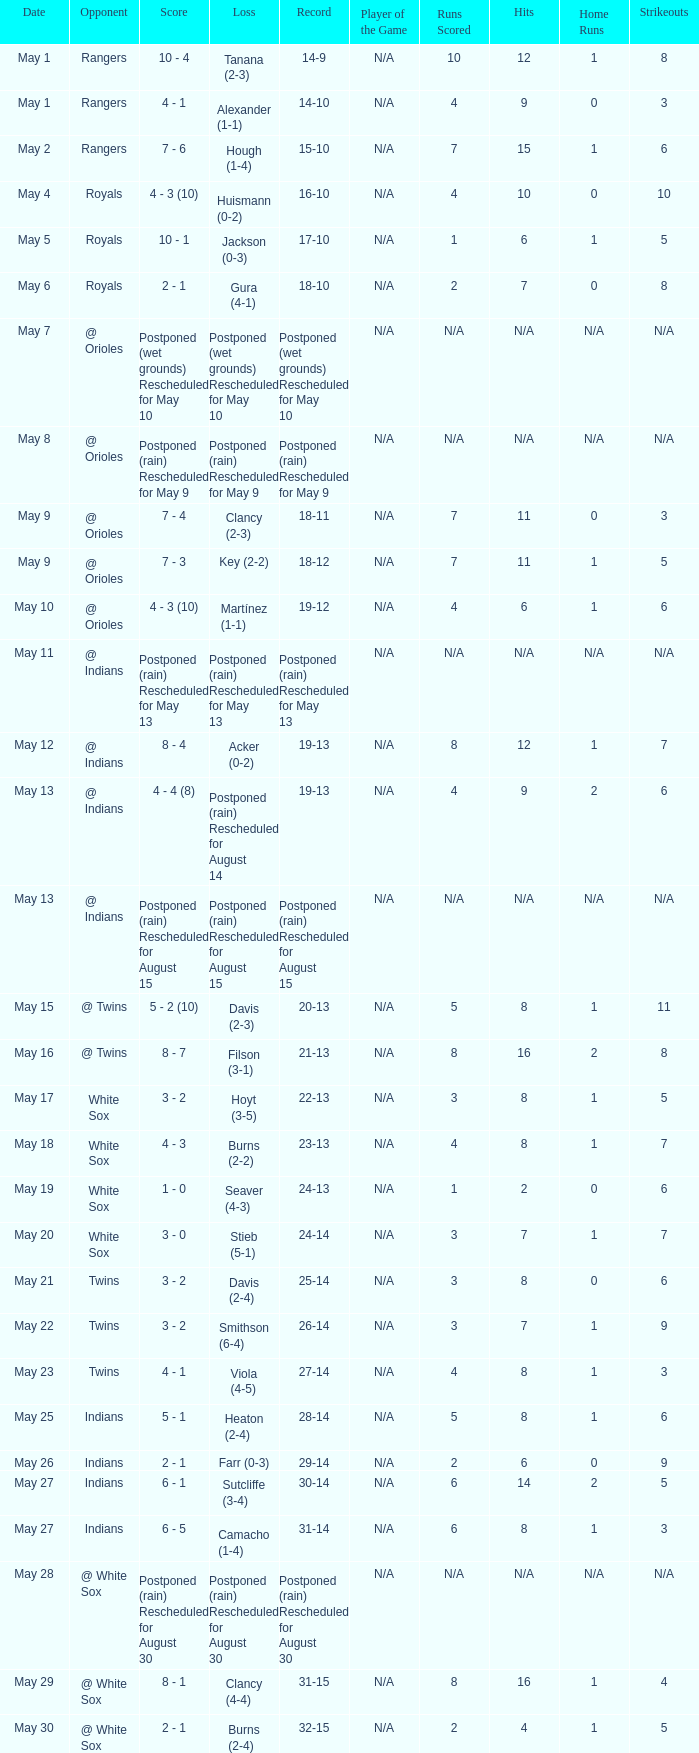Who was the opponent at the game when the record was 22-13? White Sox. 